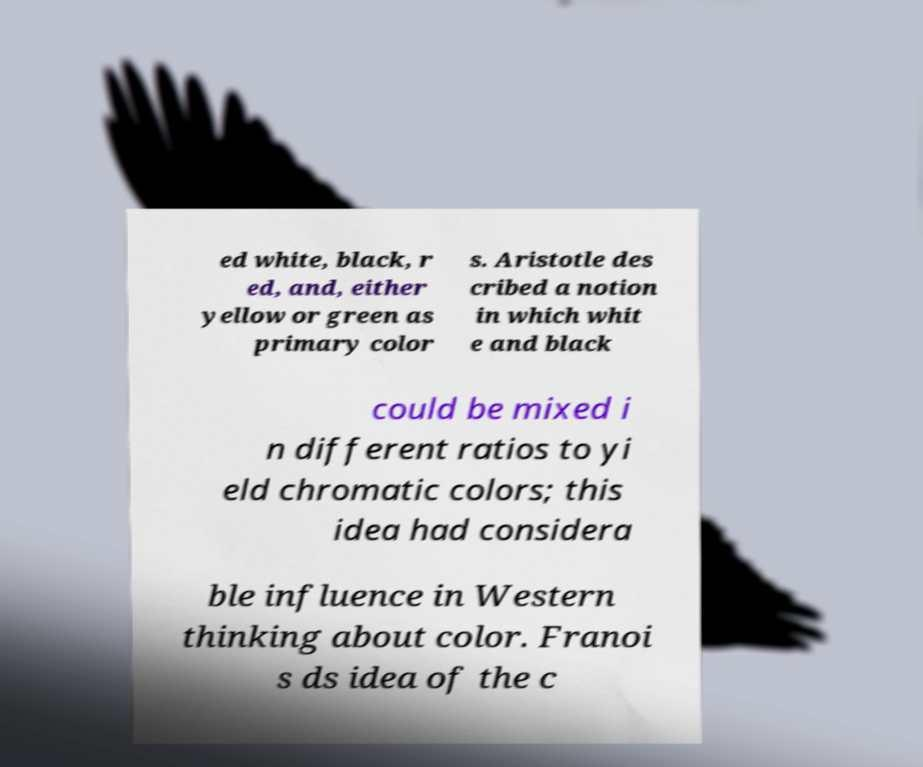For documentation purposes, I need the text within this image transcribed. Could you provide that? ed white, black, r ed, and, either yellow or green as primary color s. Aristotle des cribed a notion in which whit e and black could be mixed i n different ratios to yi eld chromatic colors; this idea had considera ble influence in Western thinking about color. Franoi s ds idea of the c 